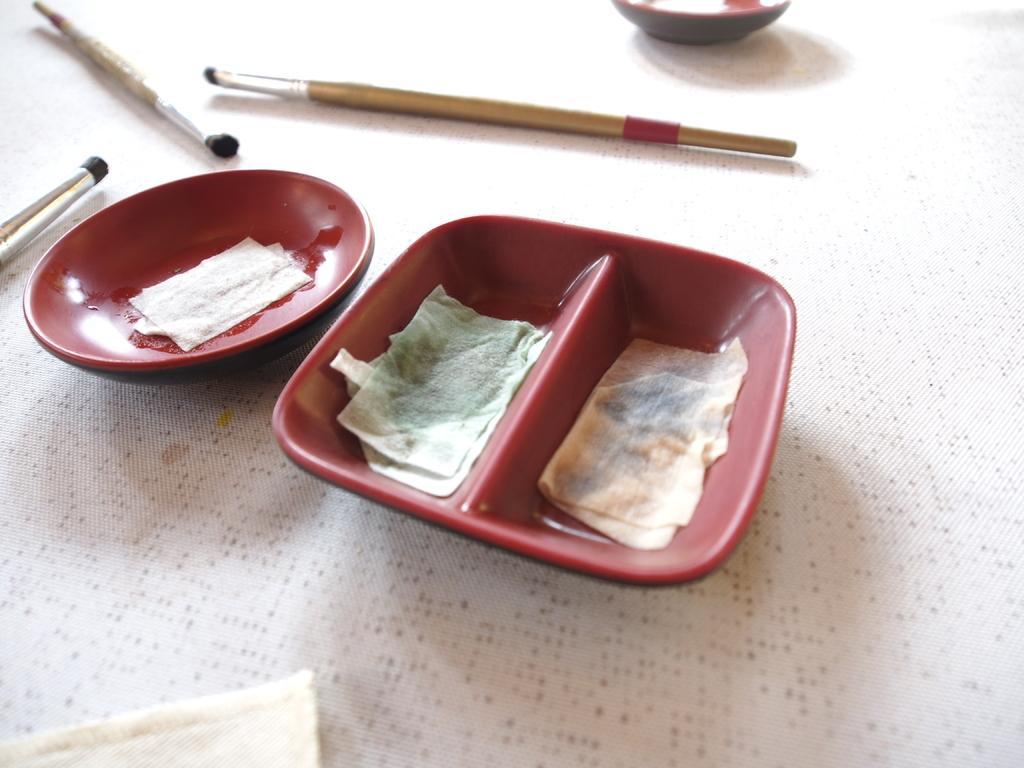Can you describe this image briefly? In this image, we can see two containers and we can see paint brushes on the cloth. 